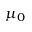Convert formula to latex. <formula><loc_0><loc_0><loc_500><loc_500>\mu _ { 0 }</formula> 